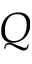Convert formula to latex. <formula><loc_0><loc_0><loc_500><loc_500>Q</formula> 